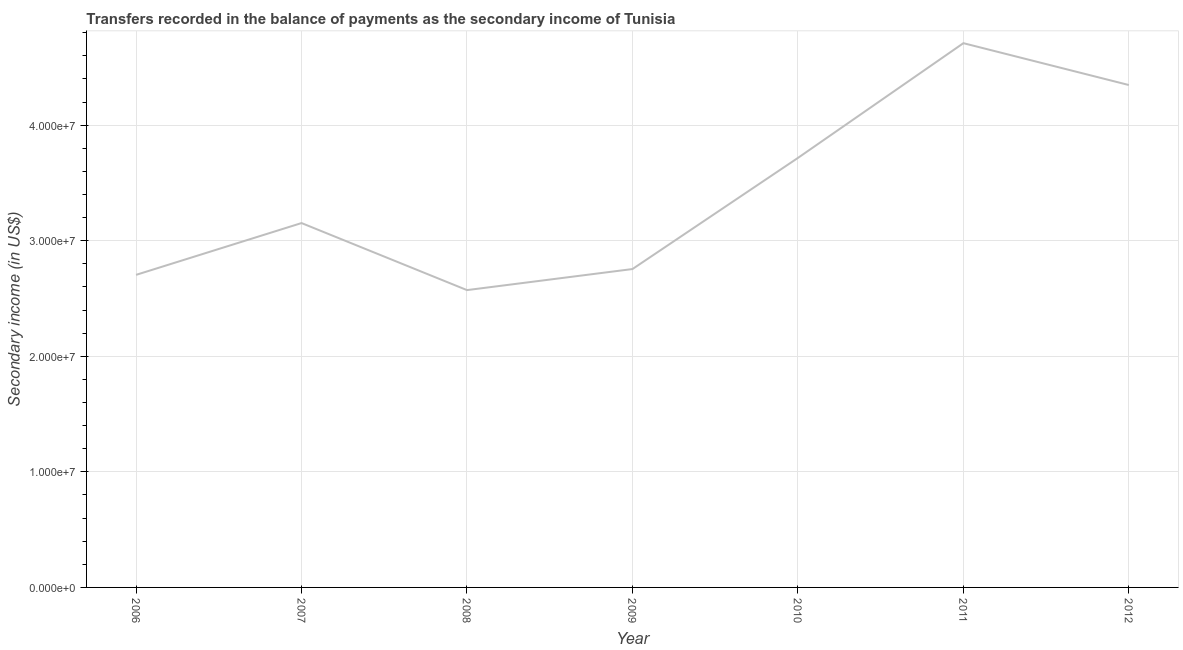What is the amount of secondary income in 2011?
Make the answer very short. 4.71e+07. Across all years, what is the maximum amount of secondary income?
Provide a short and direct response. 4.71e+07. Across all years, what is the minimum amount of secondary income?
Provide a short and direct response. 2.57e+07. What is the sum of the amount of secondary income?
Your answer should be very brief. 2.40e+08. What is the difference between the amount of secondary income in 2006 and 2010?
Make the answer very short. -1.01e+07. What is the average amount of secondary income per year?
Offer a very short reply. 3.42e+07. What is the median amount of secondary income?
Give a very brief answer. 3.15e+07. Do a majority of the years between 2006 and 2007 (inclusive) have amount of secondary income greater than 44000000 US$?
Give a very brief answer. No. What is the ratio of the amount of secondary income in 2006 to that in 2007?
Keep it short and to the point. 0.86. Is the difference between the amount of secondary income in 2008 and 2010 greater than the difference between any two years?
Offer a very short reply. No. What is the difference between the highest and the second highest amount of secondary income?
Offer a very short reply. 3.62e+06. Is the sum of the amount of secondary income in 2009 and 2011 greater than the maximum amount of secondary income across all years?
Your answer should be compact. Yes. What is the difference between the highest and the lowest amount of secondary income?
Your answer should be compact. 2.14e+07. How many years are there in the graph?
Make the answer very short. 7. What is the title of the graph?
Your answer should be compact. Transfers recorded in the balance of payments as the secondary income of Tunisia. What is the label or title of the Y-axis?
Your answer should be compact. Secondary income (in US$). What is the Secondary income (in US$) of 2006?
Your answer should be compact. 2.70e+07. What is the Secondary income (in US$) of 2007?
Ensure brevity in your answer.  3.15e+07. What is the Secondary income (in US$) in 2008?
Offer a terse response. 2.57e+07. What is the Secondary income (in US$) in 2009?
Offer a very short reply. 2.75e+07. What is the Secondary income (in US$) of 2010?
Ensure brevity in your answer.  3.72e+07. What is the Secondary income (in US$) in 2011?
Offer a very short reply. 4.71e+07. What is the Secondary income (in US$) of 2012?
Offer a terse response. 4.35e+07. What is the difference between the Secondary income (in US$) in 2006 and 2007?
Provide a short and direct response. -4.48e+06. What is the difference between the Secondary income (in US$) in 2006 and 2008?
Your response must be concise. 1.32e+06. What is the difference between the Secondary income (in US$) in 2006 and 2009?
Provide a succinct answer. -5.03e+05. What is the difference between the Secondary income (in US$) in 2006 and 2010?
Keep it short and to the point. -1.01e+07. What is the difference between the Secondary income (in US$) in 2006 and 2011?
Your answer should be compact. -2.00e+07. What is the difference between the Secondary income (in US$) in 2006 and 2012?
Your response must be concise. -1.64e+07. What is the difference between the Secondary income (in US$) in 2007 and 2008?
Your answer should be very brief. 5.80e+06. What is the difference between the Secondary income (in US$) in 2007 and 2009?
Your answer should be compact. 3.98e+06. What is the difference between the Secondary income (in US$) in 2007 and 2010?
Provide a succinct answer. -5.64e+06. What is the difference between the Secondary income (in US$) in 2007 and 2011?
Offer a very short reply. -1.56e+07. What is the difference between the Secondary income (in US$) in 2007 and 2012?
Make the answer very short. -1.19e+07. What is the difference between the Secondary income (in US$) in 2008 and 2009?
Keep it short and to the point. -1.82e+06. What is the difference between the Secondary income (in US$) in 2008 and 2010?
Your answer should be compact. -1.14e+07. What is the difference between the Secondary income (in US$) in 2008 and 2011?
Your response must be concise. -2.14e+07. What is the difference between the Secondary income (in US$) in 2008 and 2012?
Keep it short and to the point. -1.77e+07. What is the difference between the Secondary income (in US$) in 2009 and 2010?
Your answer should be compact. -9.62e+06. What is the difference between the Secondary income (in US$) in 2009 and 2011?
Your answer should be compact. -1.95e+07. What is the difference between the Secondary income (in US$) in 2009 and 2012?
Keep it short and to the point. -1.59e+07. What is the difference between the Secondary income (in US$) in 2010 and 2011?
Provide a succinct answer. -9.93e+06. What is the difference between the Secondary income (in US$) in 2010 and 2012?
Provide a succinct answer. -6.31e+06. What is the difference between the Secondary income (in US$) in 2011 and 2012?
Give a very brief answer. 3.62e+06. What is the ratio of the Secondary income (in US$) in 2006 to that in 2007?
Give a very brief answer. 0.86. What is the ratio of the Secondary income (in US$) in 2006 to that in 2008?
Keep it short and to the point. 1.05. What is the ratio of the Secondary income (in US$) in 2006 to that in 2009?
Offer a very short reply. 0.98. What is the ratio of the Secondary income (in US$) in 2006 to that in 2010?
Your answer should be compact. 0.73. What is the ratio of the Secondary income (in US$) in 2006 to that in 2011?
Your answer should be compact. 0.57. What is the ratio of the Secondary income (in US$) in 2006 to that in 2012?
Your answer should be compact. 0.62. What is the ratio of the Secondary income (in US$) in 2007 to that in 2008?
Make the answer very short. 1.23. What is the ratio of the Secondary income (in US$) in 2007 to that in 2009?
Provide a short and direct response. 1.14. What is the ratio of the Secondary income (in US$) in 2007 to that in 2010?
Make the answer very short. 0.85. What is the ratio of the Secondary income (in US$) in 2007 to that in 2011?
Keep it short and to the point. 0.67. What is the ratio of the Secondary income (in US$) in 2007 to that in 2012?
Your response must be concise. 0.72. What is the ratio of the Secondary income (in US$) in 2008 to that in 2009?
Provide a succinct answer. 0.93. What is the ratio of the Secondary income (in US$) in 2008 to that in 2010?
Your answer should be very brief. 0.69. What is the ratio of the Secondary income (in US$) in 2008 to that in 2011?
Provide a succinct answer. 0.55. What is the ratio of the Secondary income (in US$) in 2008 to that in 2012?
Ensure brevity in your answer.  0.59. What is the ratio of the Secondary income (in US$) in 2009 to that in 2010?
Your answer should be compact. 0.74. What is the ratio of the Secondary income (in US$) in 2009 to that in 2011?
Your response must be concise. 0.58. What is the ratio of the Secondary income (in US$) in 2009 to that in 2012?
Keep it short and to the point. 0.63. What is the ratio of the Secondary income (in US$) in 2010 to that in 2011?
Give a very brief answer. 0.79. What is the ratio of the Secondary income (in US$) in 2010 to that in 2012?
Provide a succinct answer. 0.85. What is the ratio of the Secondary income (in US$) in 2011 to that in 2012?
Your response must be concise. 1.08. 